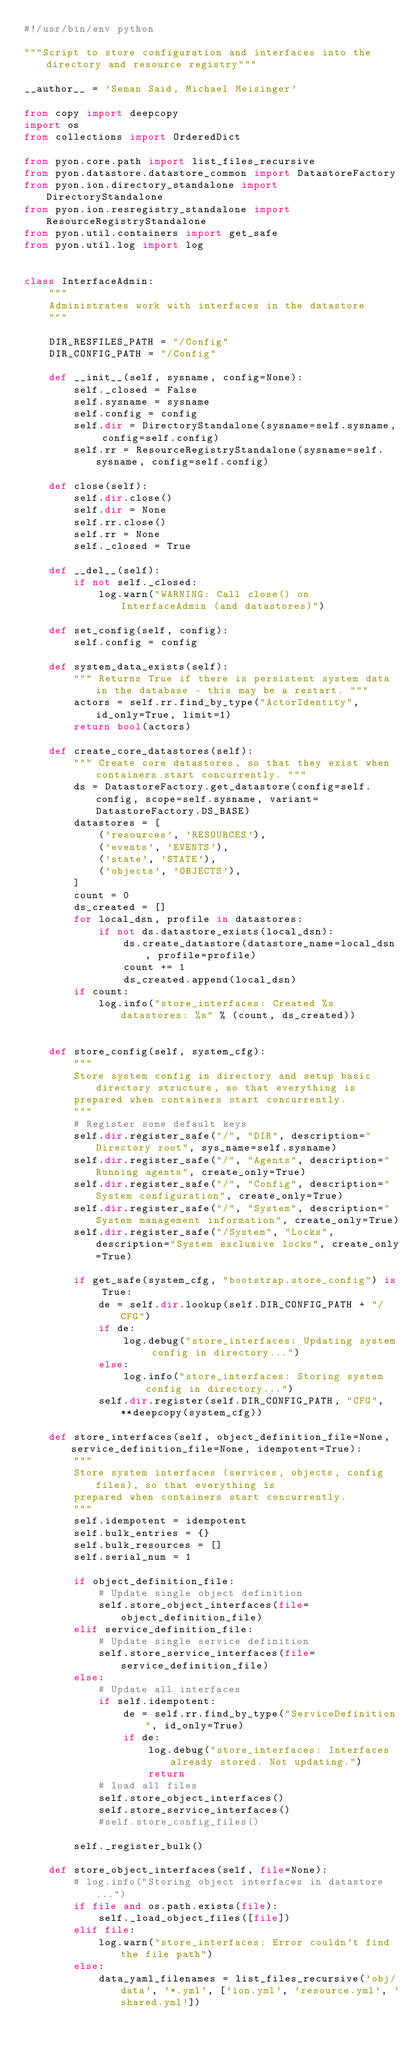Convert code to text. <code><loc_0><loc_0><loc_500><loc_500><_Python_>#!/usr/bin/env python

"""Script to store configuration and interfaces into the directory and resource registry"""

__author__ = 'Seman Said, Michael Meisinger'

from copy import deepcopy
import os
from collections import OrderedDict

from pyon.core.path import list_files_recursive
from pyon.datastore.datastore_common import DatastoreFactory
from pyon.ion.directory_standalone import DirectoryStandalone
from pyon.ion.resregistry_standalone import ResourceRegistryStandalone
from pyon.util.containers import get_safe
from pyon.util.log import log


class InterfaceAdmin:
    """
    Administrates work with interfaces in the datastore
    """

    DIR_RESFILES_PATH = "/Config"
    DIR_CONFIG_PATH = "/Config"

    def __init__(self, sysname, config=None):
        self._closed = False
        self.sysname = sysname
        self.config = config
        self.dir = DirectoryStandalone(sysname=self.sysname, config=self.config)
        self.rr = ResourceRegistryStandalone(sysname=self.sysname, config=self.config)

    def close(self):
        self.dir.close()
        self.dir = None
        self.rr.close()
        self.rr = None
        self._closed = True

    def __del__(self):
        if not self._closed:
            log.warn("WARNING: Call close() on InterfaceAdmin (and datastores)")

    def set_config(self, config):
        self.config = config

    def system_data_exists(self):
        """ Returns True if there is persistent system data in the database - this may be a restart. """
        actors = self.rr.find_by_type("ActorIdentity", id_only=True, limit=1)
        return bool(actors)

    def create_core_datastores(self):
        """ Create core datastores, so that they exist when containers start concurrently. """
        ds = DatastoreFactory.get_datastore(config=self.config, scope=self.sysname, variant=DatastoreFactory.DS_BASE)
        datastores = [
            ('resources', 'RESOURCES'),
            ('events', 'EVENTS'),
            ('state', 'STATE'),
            ('objects', 'OBJECTS'),
        ]
        count = 0
        ds_created = []
        for local_dsn, profile in datastores:
            if not ds.datastore_exists(local_dsn):
                ds.create_datastore(datastore_name=local_dsn, profile=profile)
                count += 1
                ds_created.append(local_dsn)
        if count:
            log.info("store_interfaces: Created %s datastores: %s" % (count, ds_created))


    def store_config(self, system_cfg):
        """
        Store system config in directory and setup basic directory structure, so that everything is
        prepared when containers start concurrently.
        """
        # Register some default keys
        self.dir.register_safe("/", "DIR", description="Directory root", sys_name=self.sysname)
        self.dir.register_safe("/", "Agents", description="Running agents", create_only=True)
        self.dir.register_safe("/", "Config", description="System configuration", create_only=True)
        self.dir.register_safe("/", "System", description="System management information", create_only=True)
        self.dir.register_safe("/System", "Locks", description="System exclusive locks", create_only=True)

        if get_safe(system_cfg, "bootstrap.store_config") is True:
            de = self.dir.lookup(self.DIR_CONFIG_PATH + "/CFG")
            if de:
                log.debug("store_interfaces: Updating system config in directory...")
            else:
                log.info("store_interfaces: Storing system config in directory...")
            self.dir.register(self.DIR_CONFIG_PATH, "CFG", **deepcopy(system_cfg))

    def store_interfaces(self, object_definition_file=None, service_definition_file=None, idempotent=True):
        """
        Store system interfaces (services, objects, config files), so that everything is
        prepared when containers start concurrently.
        """
        self.idempotent = idempotent
        self.bulk_entries = {}
        self.bulk_resources = []
        self.serial_num = 1

        if object_definition_file:
            # Update single object definition
            self.store_object_interfaces(file=object_definition_file)
        elif service_definition_file:
            # Update single service definition
            self.store_service_interfaces(file=service_definition_file)
        else:
            # Update all interfaces
            if self.idempotent:
                de = self.rr.find_by_type("ServiceDefinition", id_only=True)
                if de:
                    log.debug("store_interfaces: Interfaces already stored. Not updating.")
                    return
            # load all files
            self.store_object_interfaces()
            self.store_service_interfaces()
            #self.store_config_files()

        self._register_bulk()

    def store_object_interfaces(self, file=None):
        # log.info("Storing object interfaces in datastore...")
        if file and os.path.exists(file):
            self._load_object_files([file])
        elif file:
            log.warn("store_interfaces: Error couldn't find the file path")
        else:
            data_yaml_filenames = list_files_recursive('obj/data', '*.yml', ['ion.yml', 'resource.yml', 'shared.yml'])</code> 